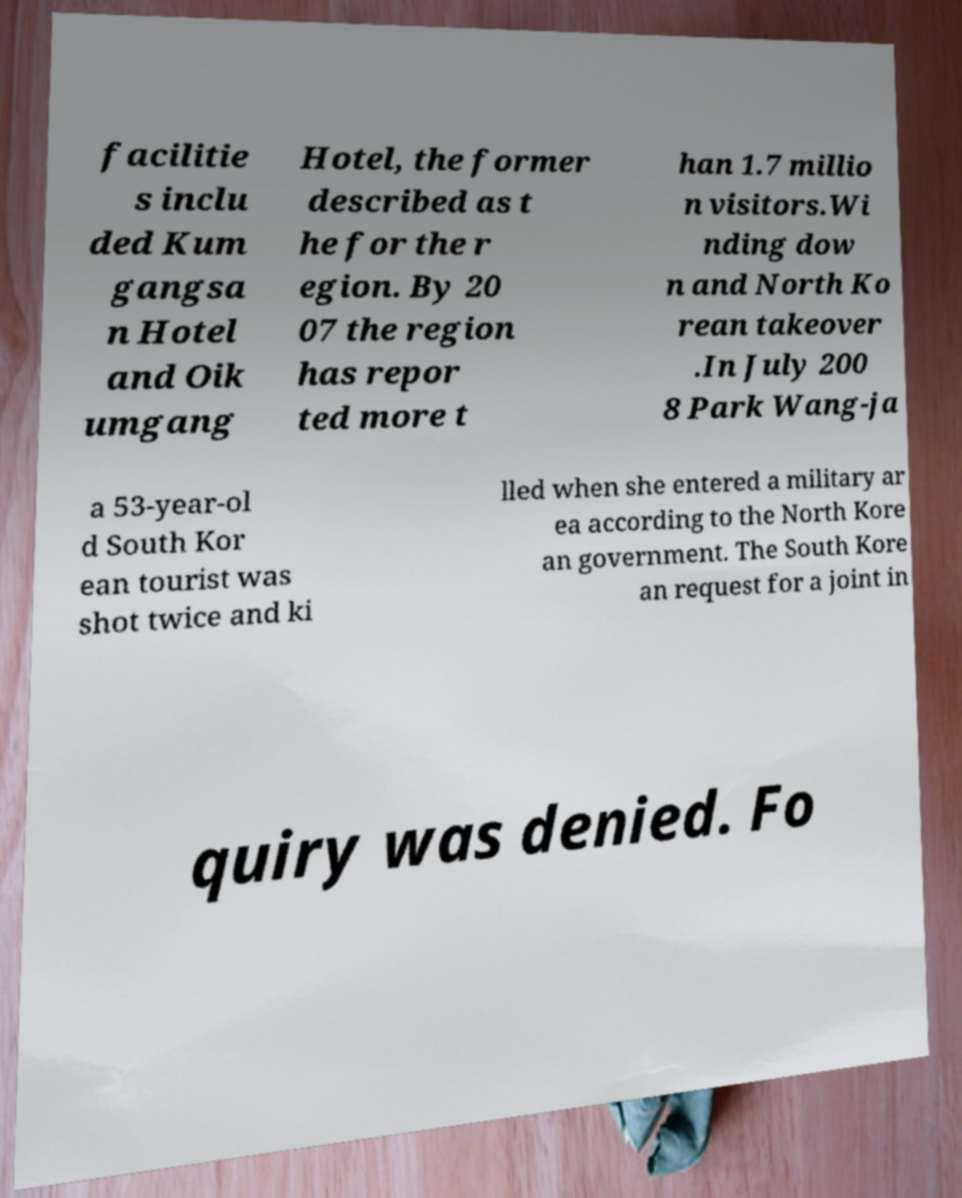Could you assist in decoding the text presented in this image and type it out clearly? facilitie s inclu ded Kum gangsa n Hotel and Oik umgang Hotel, the former described as t he for the r egion. By 20 07 the region has repor ted more t han 1.7 millio n visitors.Wi nding dow n and North Ko rean takeover .In July 200 8 Park Wang-ja a 53-year-ol d South Kor ean tourist was shot twice and ki lled when she entered a military ar ea according to the North Kore an government. The South Kore an request for a joint in quiry was denied. Fo 